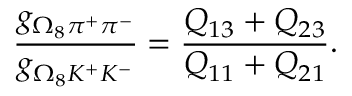Convert formula to latex. <formula><loc_0><loc_0><loc_500><loc_500>\frac { g _ { \Omega _ { 8 } \pi ^ { + } \pi ^ { - } } } { g _ { \Omega _ { 8 } K ^ { + } K ^ { - } } } = \frac { Q _ { 1 3 } + Q _ { 2 3 } } { Q _ { 1 1 } + Q _ { 2 1 } } .</formula> 